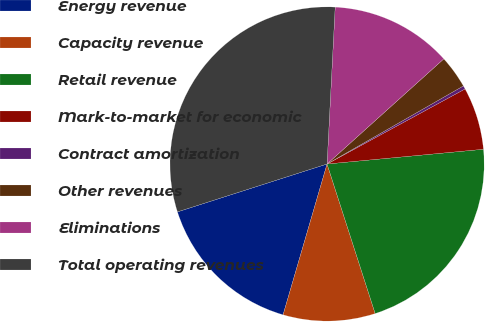<chart> <loc_0><loc_0><loc_500><loc_500><pie_chart><fcel>Energy revenue<fcel>Capacity revenue<fcel>Retail revenue<fcel>Mark-to-market for economic<fcel>Contract amortization<fcel>Other revenues<fcel>Eliminations<fcel>Total operating revenues<nl><fcel>15.55%<fcel>9.47%<fcel>21.54%<fcel>6.43%<fcel>0.35%<fcel>3.39%<fcel>12.51%<fcel>30.75%<nl></chart> 